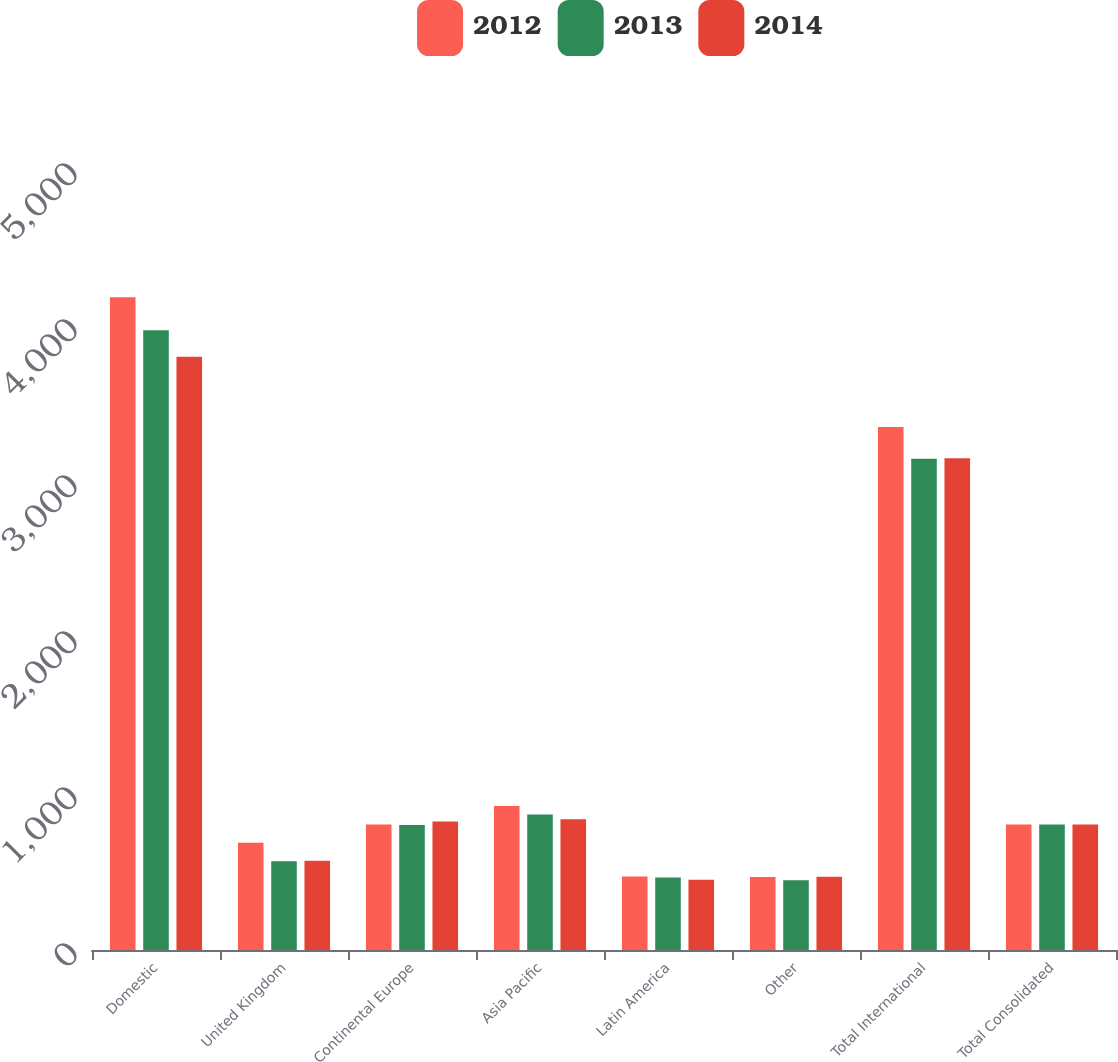Convert chart to OTSL. <chart><loc_0><loc_0><loc_500><loc_500><stacked_bar_chart><ecel><fcel>Domestic<fcel>United Kingdom<fcel>Continental Europe<fcel>Asia Pacific<fcel>Latin America<fcel>Other<fcel>Total International<fcel>Total Consolidated<nl><fcel>2012<fcel>4184<fcel>688.3<fcel>804.7<fcel>922.5<fcel>470.4<fcel>467.2<fcel>3353.1<fcel>804.7<nl><fcel>2013<fcel>3972.6<fcel>568.3<fcel>800.6<fcel>868.9<fcel>464.5<fcel>447.4<fcel>3149.7<fcel>804.7<nl><fcel>2014<fcel>3803.6<fcel>572<fcel>823.1<fcel>838.1<fcel>450.1<fcel>469.3<fcel>3152.6<fcel>804.7<nl></chart> 